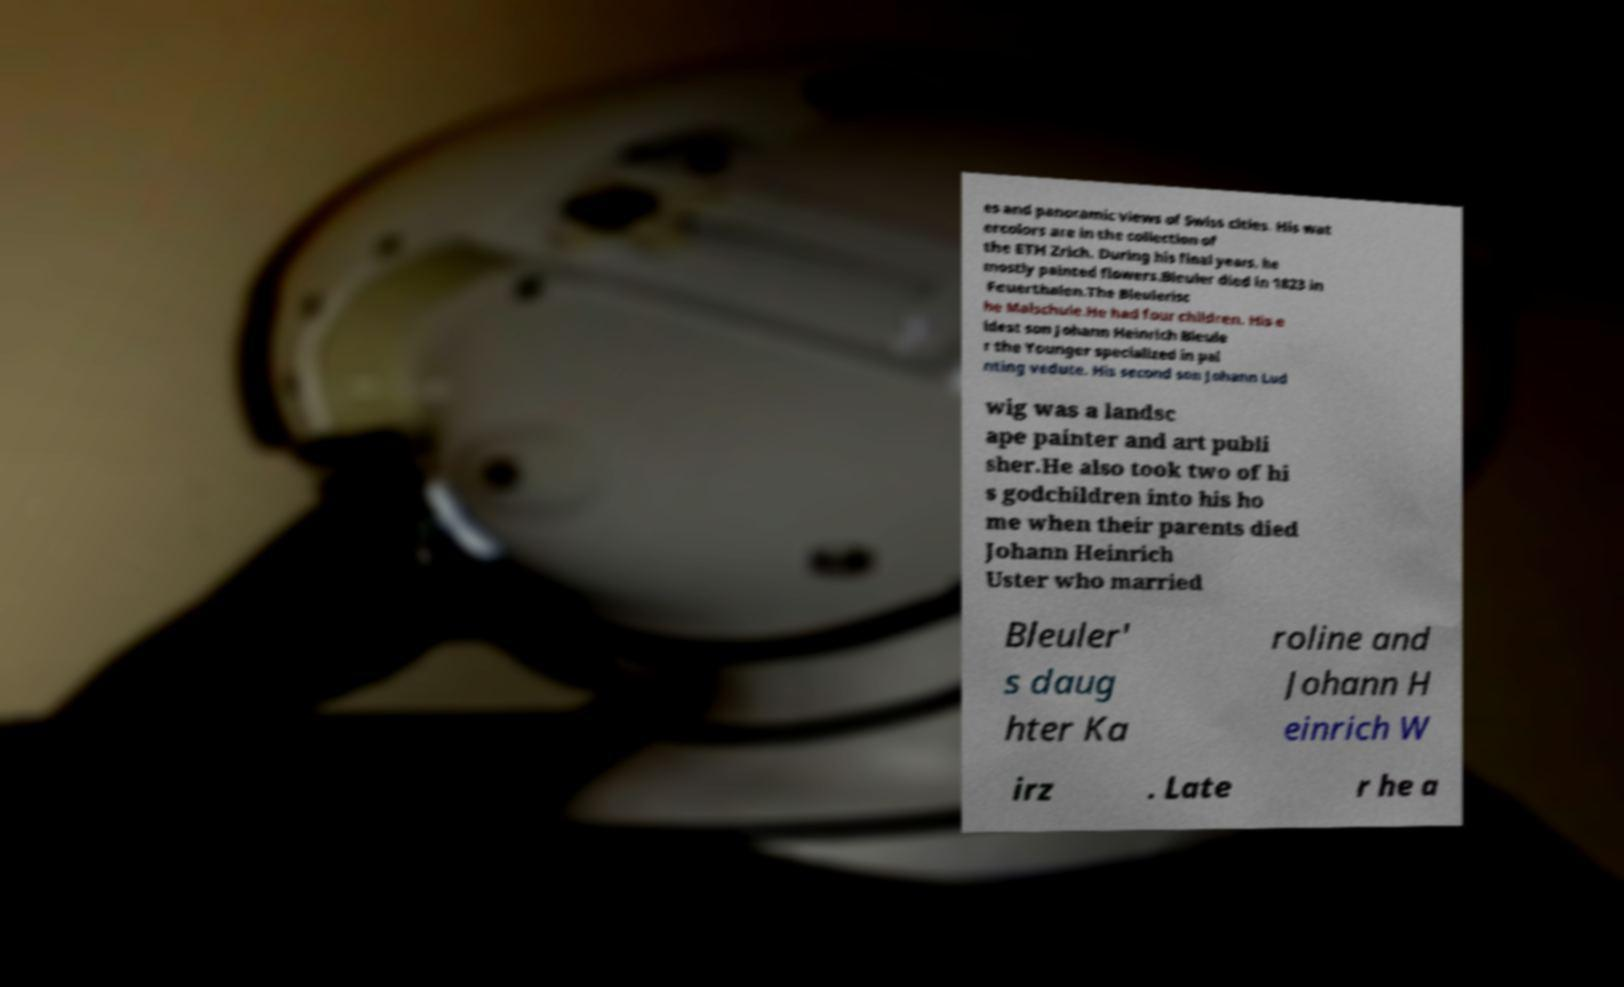I need the written content from this picture converted into text. Can you do that? es and panoramic views of Swiss cities. His wat ercolors are in the collection of the ETH Zrich. During his final years, he mostly painted flowers.Bleuler died in 1823 in Feuerthalen.The Bleulerisc he Malschule.He had four children. His e ldest son Johann Heinrich Bleule r the Younger specialized in pai nting vedute. His second son Johann Lud wig was a landsc ape painter and art publi sher.He also took two of hi s godchildren into his ho me when their parents died Johann Heinrich Uster who married Bleuler' s daug hter Ka roline and Johann H einrich W irz . Late r he a 